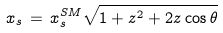Convert formula to latex. <formula><loc_0><loc_0><loc_500><loc_500>x _ { s } \, = \, x _ { s } ^ { S M } \sqrt { 1 + z ^ { 2 } + 2 z \cos \theta } \,</formula> 